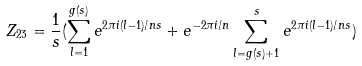Convert formula to latex. <formula><loc_0><loc_0><loc_500><loc_500>Z _ { 2 3 } = \frac { 1 } { s } ( \sum _ { l = 1 } ^ { g ( s ) } e ^ { 2 \pi i ( l - 1 ) / n s } + e ^ { - 2 \pi i / n } \sum _ { l = g ( s ) + 1 } ^ { s } e ^ { 2 \pi i ( l - 1 ) / n s } )</formula> 